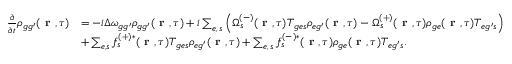Convert formula to latex. <formula><loc_0><loc_0><loc_500><loc_500>\begin{array} { r l } { \frac { \partial } { \partial t } \rho _ { { g g ^ { \prime } } } ( r , \tau ) } & { = - i \Delta \omega _ { { g g ^ { \prime } } } \rho _ { { g g ^ { \prime } } } ( r , \tau ) + i \sum _ { e , \, s } \left ( \Omega _ { s } ^ { ( - ) } ( r , \tau ) T _ { { g e } s } \rho _ { { e g ^ { \prime } } } ( r , \tau ) - \Omega _ { s } ^ { ( + ) } ( r , \tau ) \rho _ { g e } ( r , \tau ) T _ { { e g ^ { \prime } } s } \right ) } \\ & { + \sum _ { e , s } f _ { s } ^ { ( + ) * } ( r , \tau ) T _ { { g e } s } \rho _ { { e g ^ { \prime } } } ( r , \tau ) + \sum _ { e , \, s } f _ { s } ^ { ( - ) * } ( r , \tau ) \rho _ { g e } ( r , \tau ) T _ { { e g ^ { \prime } } s } . } \end{array}</formula> 